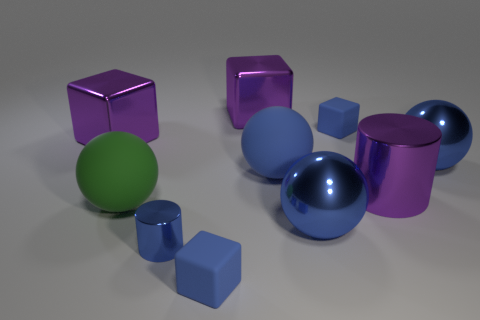Subtract all big green spheres. How many spheres are left? 3 Subtract all gray cubes. How many blue spheres are left? 3 Subtract all green spheres. How many spheres are left? 3 Subtract 1 spheres. How many spheres are left? 3 Subtract all spheres. How many objects are left? 6 Subtract all yellow spheres. Subtract all yellow cylinders. How many spheres are left? 4 Subtract all blue balls. Subtract all big blue metal spheres. How many objects are left? 5 Add 3 large purple things. How many large purple things are left? 6 Add 4 blue cylinders. How many blue cylinders exist? 5 Subtract 0 gray cubes. How many objects are left? 10 